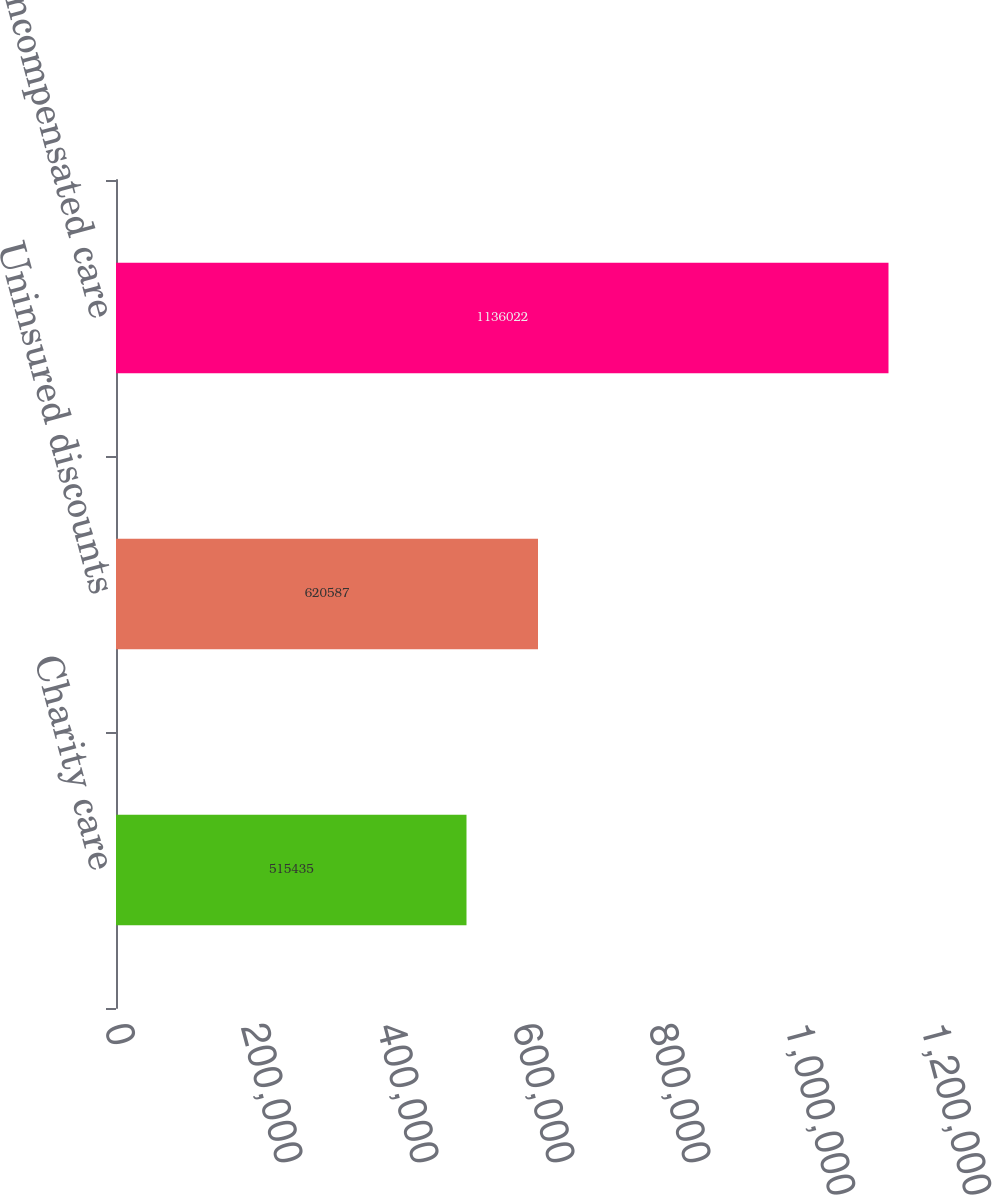Convert chart. <chart><loc_0><loc_0><loc_500><loc_500><bar_chart><fcel>Charity care<fcel>Uninsured discounts<fcel>Total uncompensated care<nl><fcel>515435<fcel>620587<fcel>1.13602e+06<nl></chart> 